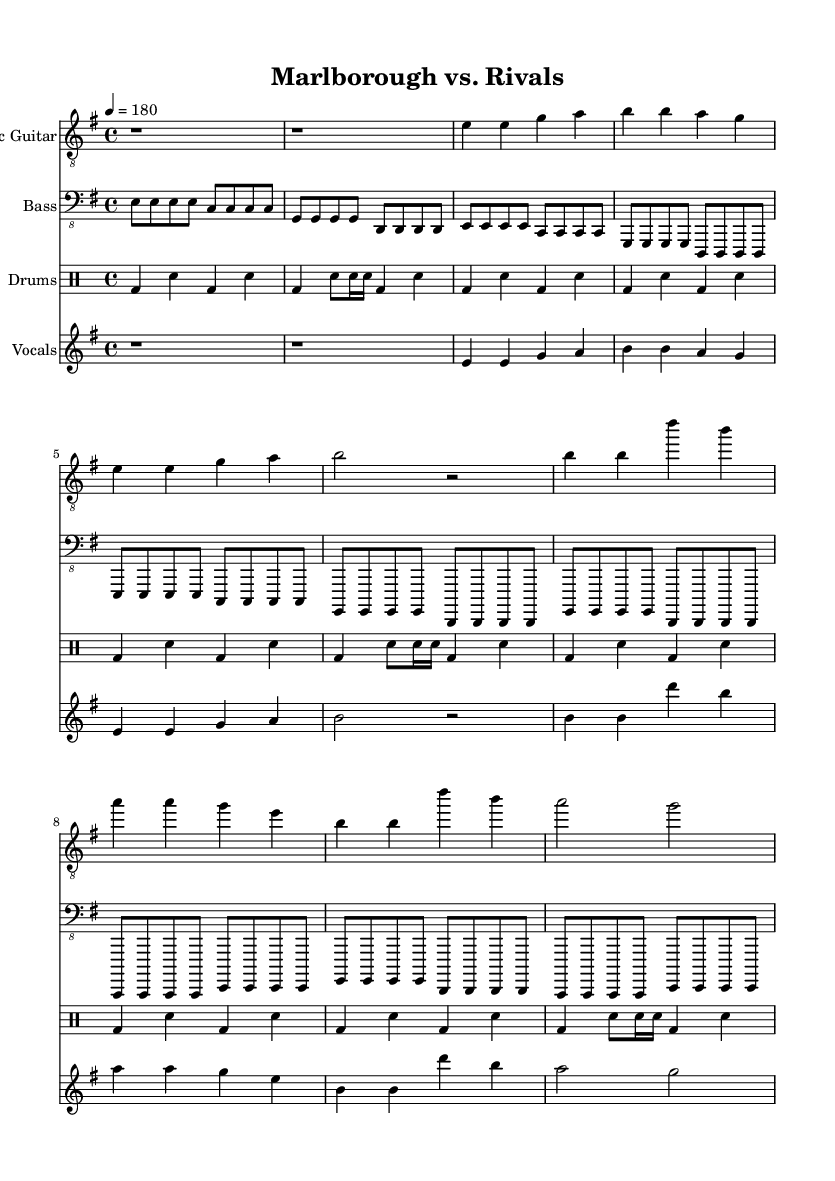What is the key signature of this music? The key signature is indicated by the number of sharps or flats at the beginning of the staff. This piece is in E minor, which has one sharp (F#).
Answer: E minor What is the time signature of this music? The time signature is shown at the beginning of the piece. It indicates that there are four beats per measure and the quarter note gets one beat, which is represented as 4/4.
Answer: 4/4 What is the tempo marking for this piece? The tempo marking is given at the beginning and indicates the speed of the music. It is written as "4 = 180," which means there are 180 beats per minute.
Answer: 180 What instruments are included in this score? The score lists specific instruments under each staff. The instruments included are Electric Guitar, Bass, Drums, and Vocals.
Answer: Electric Guitar, Bass, Drums, Vocals How many measures are in the verse section of the song? To find the number of measures in the verse section, we count the number of complete measures in the electric guitar part that falls under the verse. There are 4 measures in the verse.
Answer: 4 What words are sung during the chorus? The text of the chorus is written in the lyrics section of the score. It specifically states, "We're the kings of the game, You know our name, Marlborough Football, undefeated fame!"
Answer: We're the kings of the game, You know our name, Marlborough Football, undefeated fame! How does the rhythm of the vocals compare to the drums in the chorus? To determine the relationship between the rhythm of the vocals and the drums in the chorus, we analyze the rhythmic patterns in each part. The vocals follow a steady rhythmic pattern while the drums complement it with varied accents.
Answer: Steady vs. varied accents 